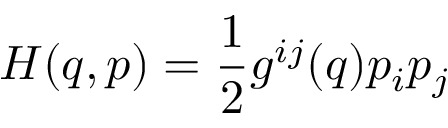Convert formula to latex. <formula><loc_0><loc_0><loc_500><loc_500>H ( q , p ) = { \frac { 1 } { 2 } } g ^ { i j } ( q ) p _ { i } p _ { j }</formula> 